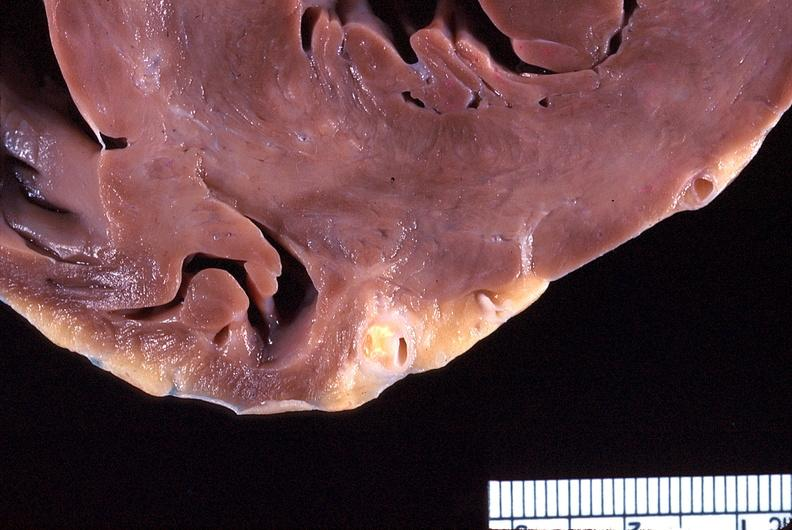what is present?
Answer the question using a single word or phrase. Cardiovascular 